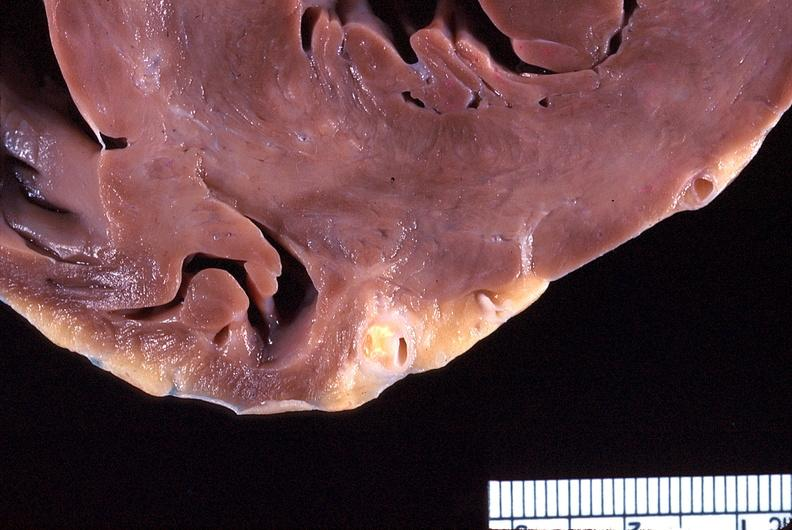what is present?
Answer the question using a single word or phrase. Cardiovascular 